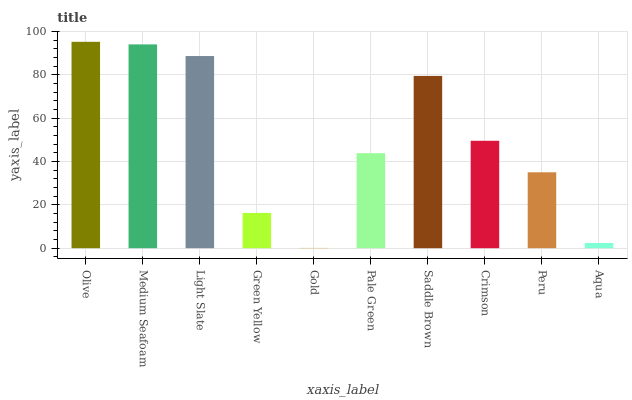Is Medium Seafoam the minimum?
Answer yes or no. No. Is Medium Seafoam the maximum?
Answer yes or no. No. Is Olive greater than Medium Seafoam?
Answer yes or no. Yes. Is Medium Seafoam less than Olive?
Answer yes or no. Yes. Is Medium Seafoam greater than Olive?
Answer yes or no. No. Is Olive less than Medium Seafoam?
Answer yes or no. No. Is Crimson the high median?
Answer yes or no. Yes. Is Pale Green the low median?
Answer yes or no. Yes. Is Medium Seafoam the high median?
Answer yes or no. No. Is Light Slate the low median?
Answer yes or no. No. 